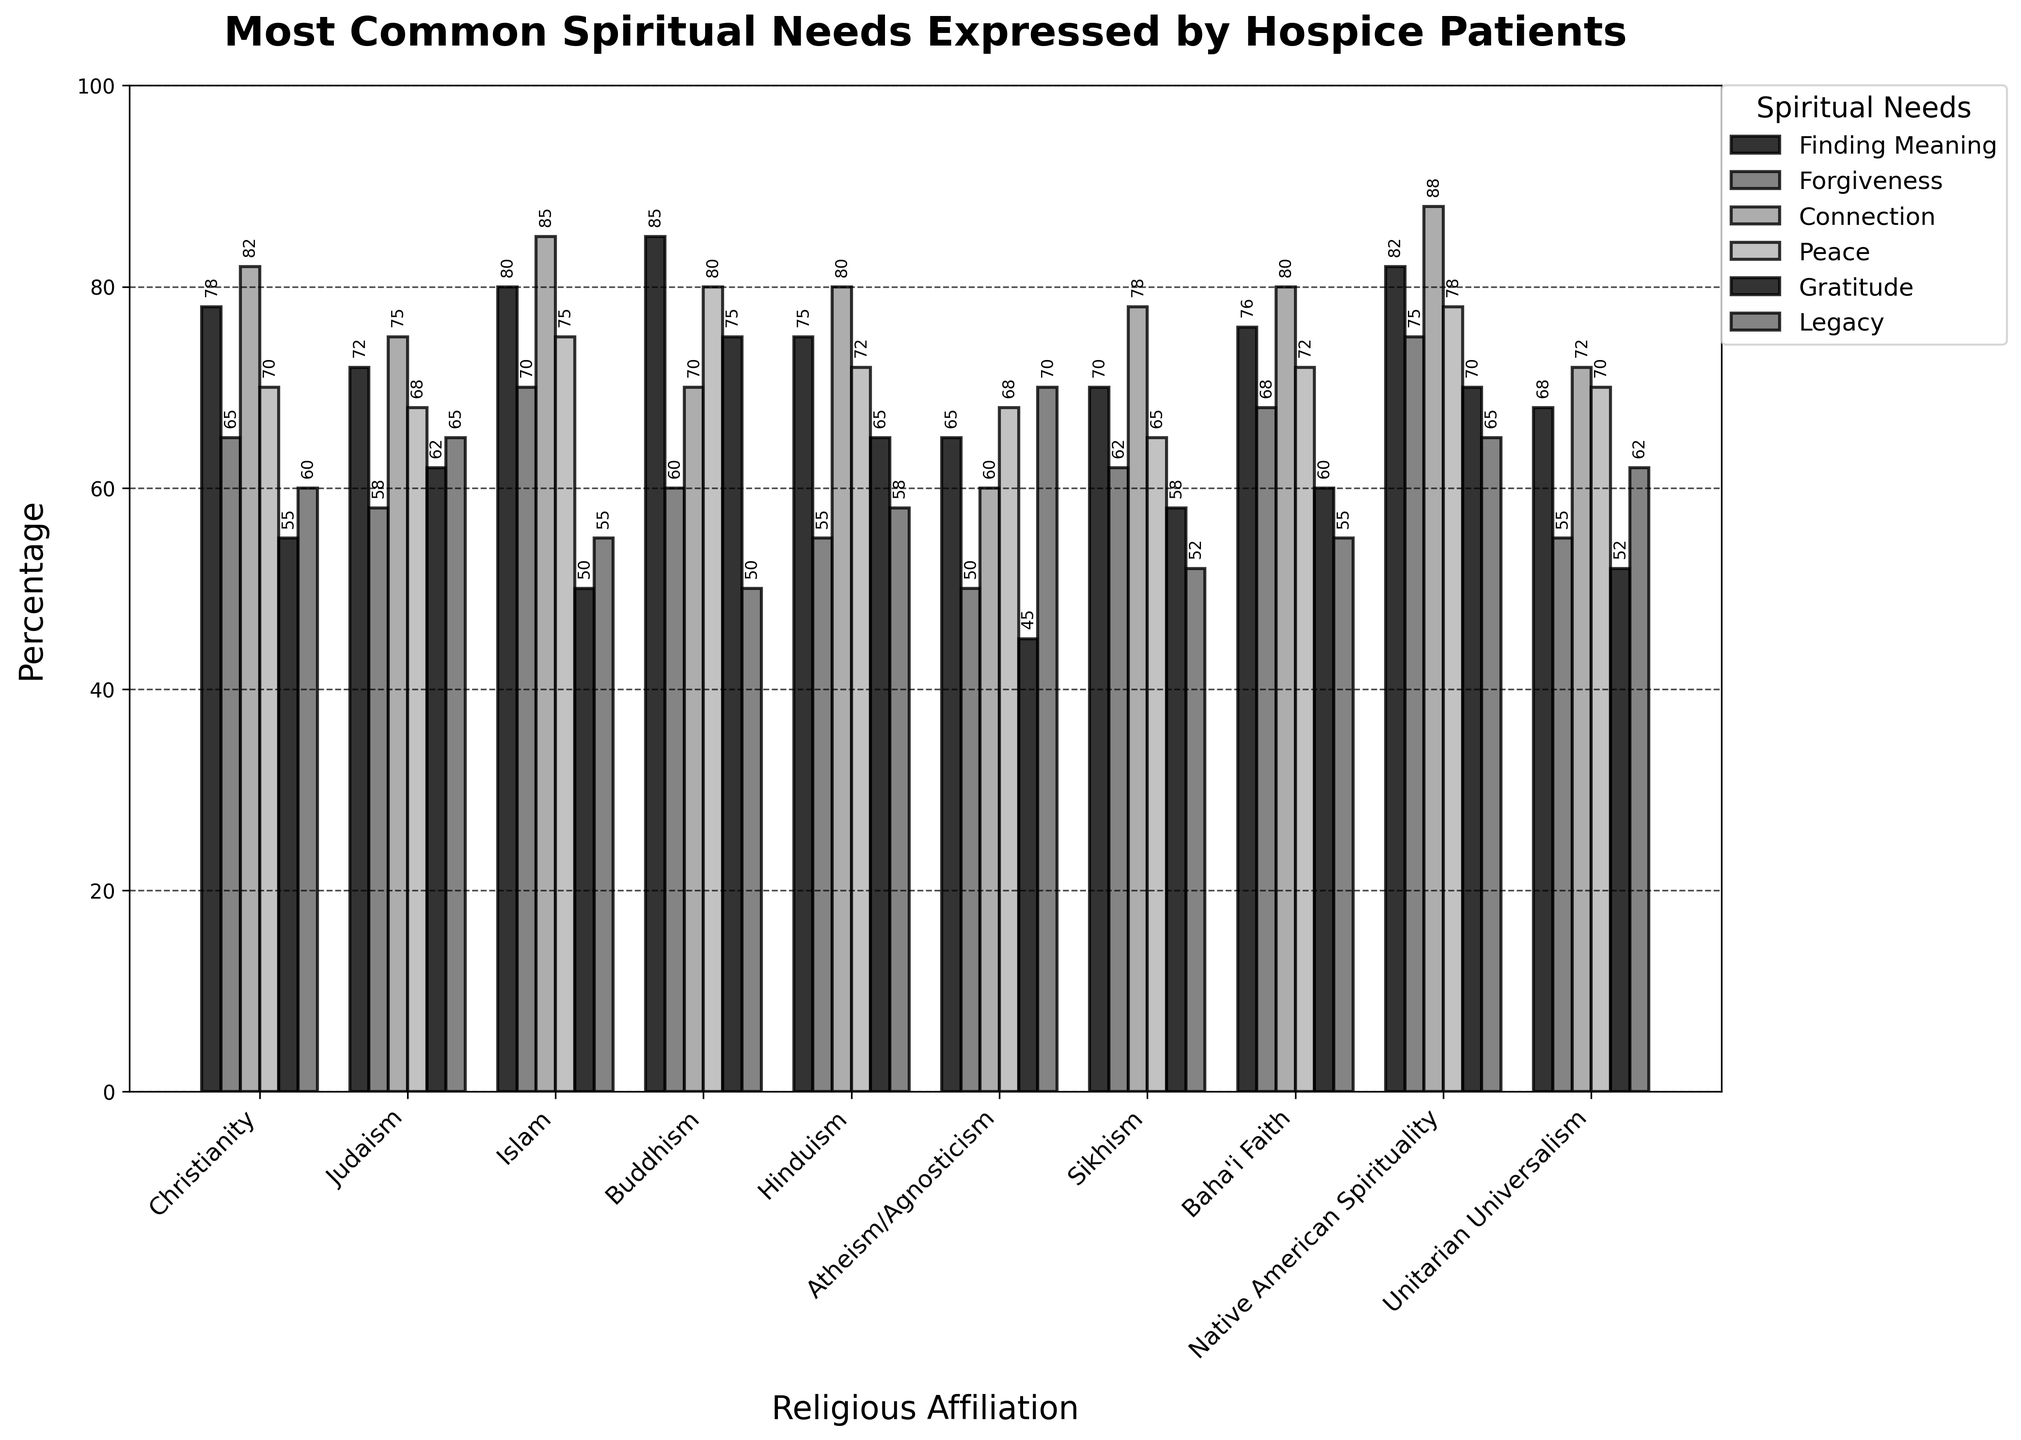Which religious affiliation has the highest reported need for 'Peace'? First, identify the 'Peace' category. Observe the bars corresponding to 'Peace' across all religious affiliations. The tallest bar for 'Peace' belongs to Islam with a value of 75.
Answer: Islam Which religious affiliation has the lowest reported need for 'Forgiveness'? First, locate the 'Forgiveness' category. Observe the bars corresponding to 'Forgiveness' across all religious affiliations. The shortest bar for 'Forgiveness' belongs to Atheism/Agnosticism with a value of 50.
Answer: Atheism/Agnosticism How much higher is the 'Finding Meaning' need in Buddhism compared to Judaism? Find the values for 'Finding Meaning' for both Buddhism and Judaism, which are 85 and 72 respectively. Subtract the value for Judaism from Buddhism (85 - 72).
Answer: 13 What is the average 'Connection' need across all religious affiliations? List the 'Connection' values: 82, 75, 85, 70, 80, 60, 78, 80, 88, 72. Sum these values: 82+75+85+70+80+60+78+80+88+72 = 770. Divide by the number of affiliations (10).
Answer: 77 Which spiritual need has the highest value for any religious affiliation? Identify the highest value in each category and compare them: 'Finding Meaning' (85), 'Forgiveness' (75), 'Connection' (88), 'Peace' (80), 'Gratitude' (75), 'Legacy' (70). 'Connection' under Native American Spirituality is the highest overall with a value of 88.
Answer: Connection, Native American Spirituality How many spiritual needs for Native American Spirituality are above 70%? Check the values for 'Finding Meaning', 'Forgiveness', 'Connection', 'Peace', 'Gratitude', and 'Legacy' in Native American Spirituality: 82, 75, 88, 78, 70, 65. Count those above 70: 'Finding Meaning' (82), 'Forgiveness' (75), 'Connection' (88), 'Peace' (78), 'Gratitude' (70), 'Legacy' (65).
Answer: 4 Which spiritual need has no values below 50% across all religious affiliations? Check each spiritual need across all religious affiliations. 'Connection' has the lowest value of 60, meaning no value is below 50.
Answer: Connection What is the difference between the highest and lowest reported need for 'Gratitude'? Identify the highest and lowest 'Gratitude' values: Buddhism (75) and Atheism/Agnosticism (45). Subtract the lowest from the highest (75 - 45).
Answer: 30 Between Christianity and Judaism, which affiliation reports a higher need for 'Legacy'? Compare the 'Legacy' values for Christianity (60) and Judaism (65). Judaism has a higher value.
Answer: Judaism 